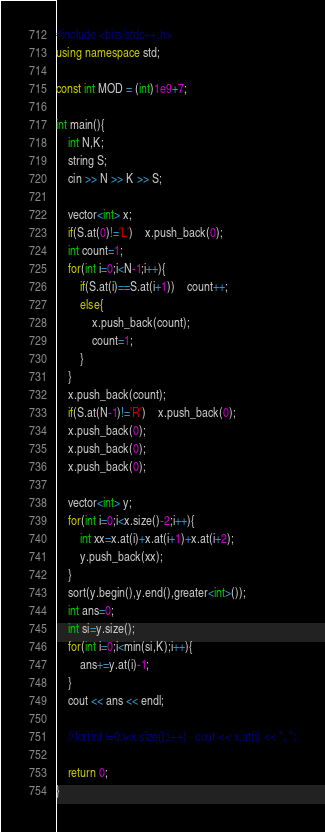<code> <loc_0><loc_0><loc_500><loc_500><_C++_>#include <bits/stdc++.h>
using namespace std;

const int MOD = (int)1e9+7;

int main(){
	int N,K;
	string S;
	cin >> N >> K >> S;

	vector<int> x;
	if(S.at(0)!='L')	x.push_back(0);
	int count=1;
	for(int i=0;i<N-1;i++){
		if(S.at(i)==S.at(i+1))	count++;
		else{
			x.push_back(count);
			count=1;
		}
	}
	x.push_back(count);
	if(S.at(N-1)!='R')	x.push_back(0);
	x.push_back(0);
	x.push_back(0);
	x.push_back(0);	

	vector<int> y;
	for(int i=0;i<x.size()-2;i++){
		int xx=x.at(i)+x.at(i+1)+x.at(i+2);
		y.push_back(xx);
	}
	sort(y.begin(),y.end(),greater<int>());
	int ans=0;
	int si=y.size();
	for(int i=0;i<min(si,K);i++){
		ans+=y.at(i)-1;
	}
	cout << ans << endl;

	//for(int i=0;i<x.size();i++)	cout << x.at(i) << ", ";
	
	return 0;
}
</code> 